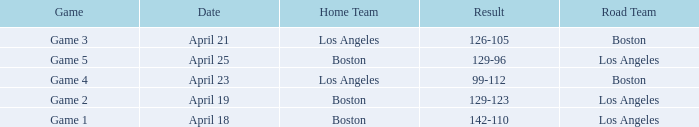WHAT GAME HAD A SCORE OF 99-112? Game 4. 